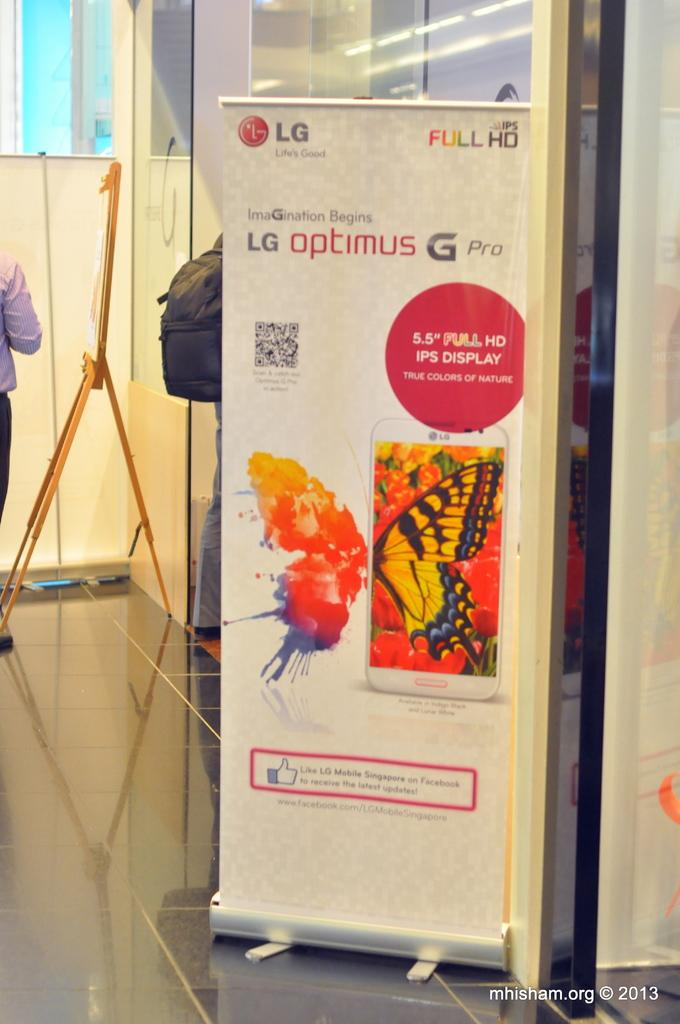<image>
Share a concise interpretation of the image provided. A banner advertising the visual quality of the LG Optimus G Pro smartphone. 